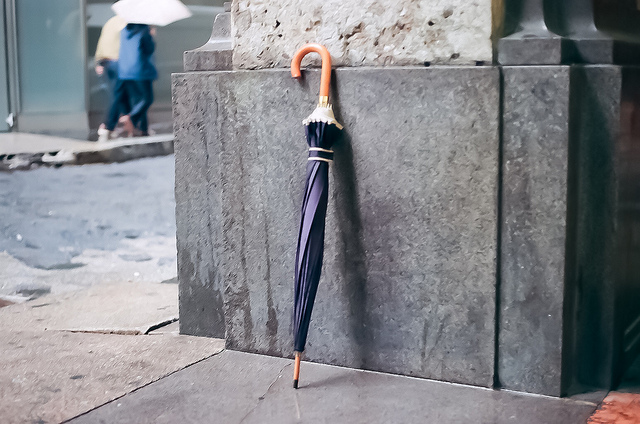How many umbrellas do you see? I see one umbrella. It's a classic design with a curved handle, leaning against a grey wall on what appears to be an urban sidewalk. 